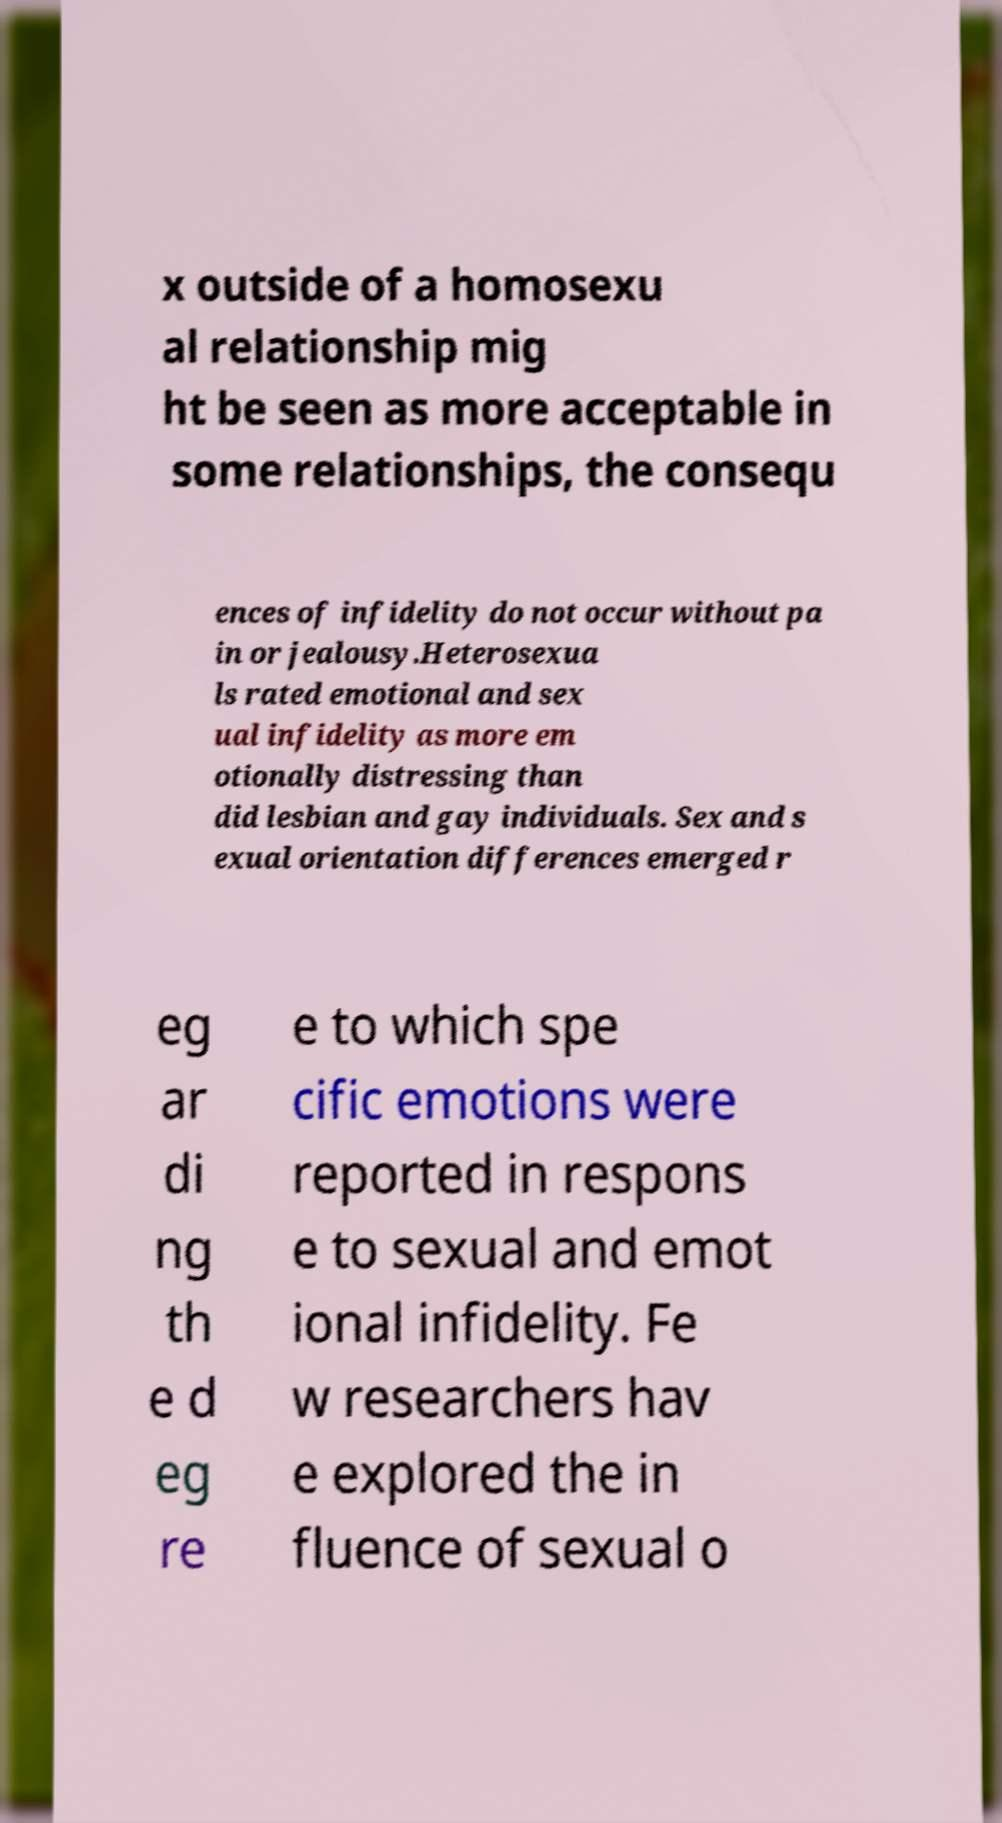I need the written content from this picture converted into text. Can you do that? x outside of a homosexu al relationship mig ht be seen as more acceptable in some relationships, the consequ ences of infidelity do not occur without pa in or jealousy.Heterosexua ls rated emotional and sex ual infidelity as more em otionally distressing than did lesbian and gay individuals. Sex and s exual orientation differences emerged r eg ar di ng th e d eg re e to which spe cific emotions were reported in respons e to sexual and emot ional infidelity. Fe w researchers hav e explored the in fluence of sexual o 